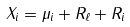Convert formula to latex. <formula><loc_0><loc_0><loc_500><loc_500>X _ { i } = \mu _ { i } + R _ { \ell } + R _ { i }</formula> 